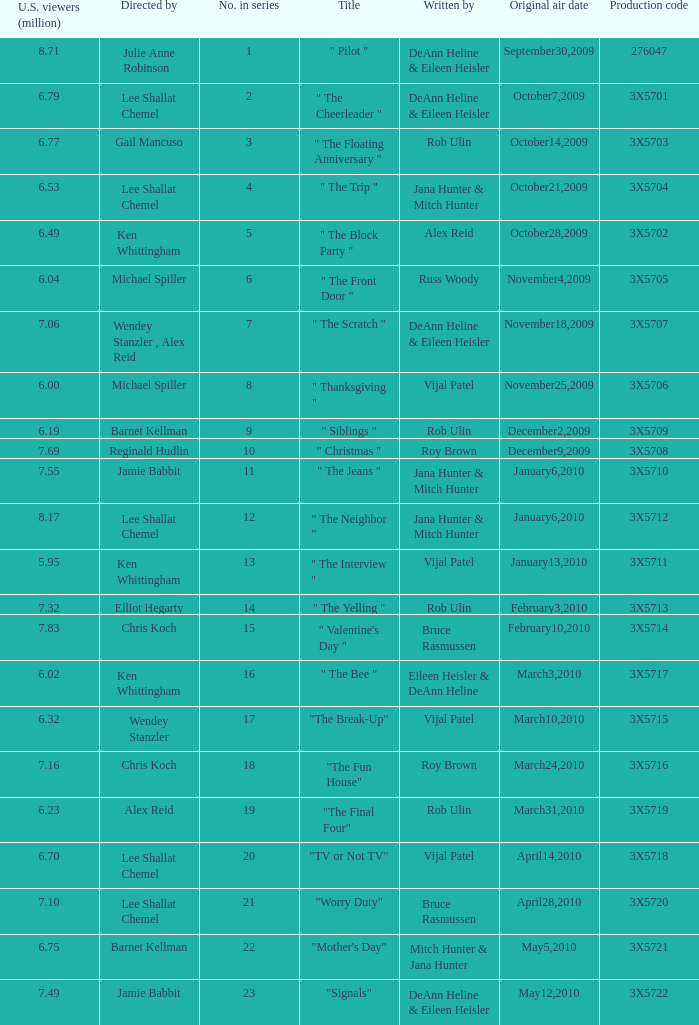How many directors got 6.79 million U.S. viewers from their episodes? 1.0. 